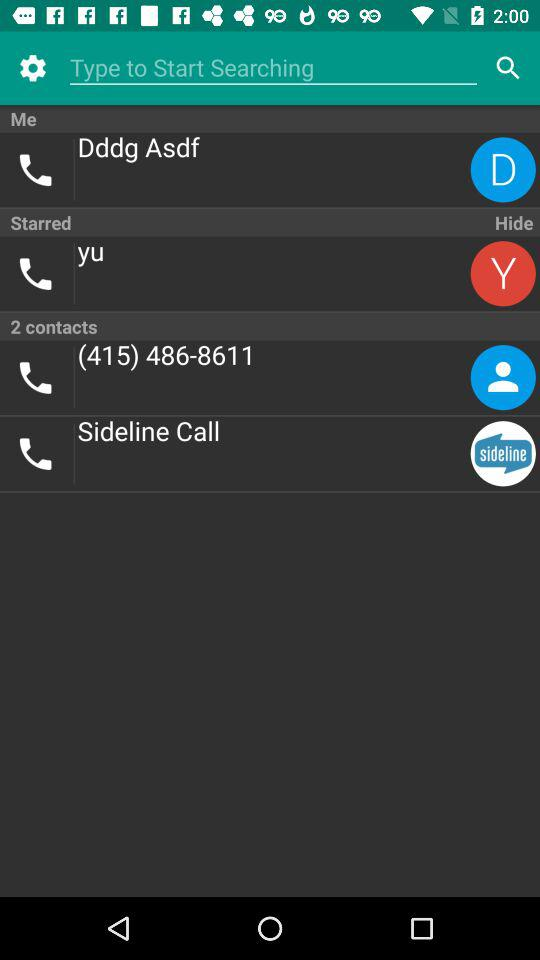What is the phone number? The phone number is (415) 486-8611. 